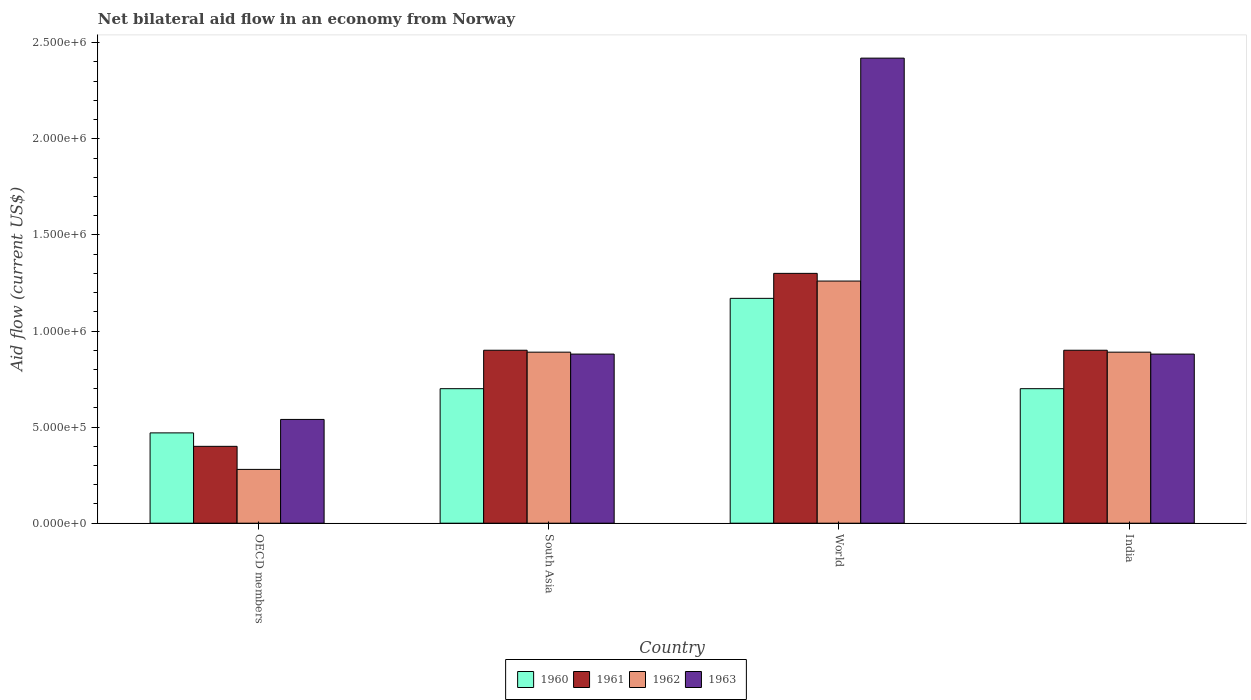How many different coloured bars are there?
Keep it short and to the point. 4. How many groups of bars are there?
Ensure brevity in your answer.  4. Are the number of bars per tick equal to the number of legend labels?
Offer a terse response. Yes. How many bars are there on the 4th tick from the right?
Offer a very short reply. 4. What is the net bilateral aid flow in 1960 in South Asia?
Ensure brevity in your answer.  7.00e+05. Across all countries, what is the maximum net bilateral aid flow in 1963?
Make the answer very short. 2.42e+06. Across all countries, what is the minimum net bilateral aid flow in 1961?
Your answer should be very brief. 4.00e+05. What is the total net bilateral aid flow in 1962 in the graph?
Your answer should be very brief. 3.32e+06. What is the difference between the net bilateral aid flow in 1962 in India and that in OECD members?
Your answer should be very brief. 6.10e+05. What is the difference between the net bilateral aid flow in 1963 in India and the net bilateral aid flow in 1962 in World?
Make the answer very short. -3.80e+05. What is the average net bilateral aid flow in 1960 per country?
Ensure brevity in your answer.  7.60e+05. What is the difference between the net bilateral aid flow of/in 1961 and net bilateral aid flow of/in 1963 in South Asia?
Your answer should be compact. 2.00e+04. What is the ratio of the net bilateral aid flow in 1960 in OECD members to that in South Asia?
Provide a succinct answer. 0.67. What is the difference between the highest and the lowest net bilateral aid flow in 1962?
Your response must be concise. 9.80e+05. Is the sum of the net bilateral aid flow in 1960 in South Asia and World greater than the maximum net bilateral aid flow in 1962 across all countries?
Your response must be concise. Yes. What does the 4th bar from the right in OECD members represents?
Offer a very short reply. 1960. Are all the bars in the graph horizontal?
Provide a succinct answer. No. What is the difference between two consecutive major ticks on the Y-axis?
Ensure brevity in your answer.  5.00e+05. Are the values on the major ticks of Y-axis written in scientific E-notation?
Give a very brief answer. Yes. How are the legend labels stacked?
Keep it short and to the point. Horizontal. What is the title of the graph?
Provide a succinct answer. Net bilateral aid flow in an economy from Norway. What is the Aid flow (current US$) of 1962 in OECD members?
Offer a terse response. 2.80e+05. What is the Aid flow (current US$) in 1963 in OECD members?
Your answer should be very brief. 5.40e+05. What is the Aid flow (current US$) in 1960 in South Asia?
Make the answer very short. 7.00e+05. What is the Aid flow (current US$) of 1962 in South Asia?
Offer a very short reply. 8.90e+05. What is the Aid flow (current US$) of 1963 in South Asia?
Your response must be concise. 8.80e+05. What is the Aid flow (current US$) in 1960 in World?
Ensure brevity in your answer.  1.17e+06. What is the Aid flow (current US$) in 1961 in World?
Your response must be concise. 1.30e+06. What is the Aid flow (current US$) of 1962 in World?
Ensure brevity in your answer.  1.26e+06. What is the Aid flow (current US$) of 1963 in World?
Your answer should be very brief. 2.42e+06. What is the Aid flow (current US$) of 1962 in India?
Make the answer very short. 8.90e+05. What is the Aid flow (current US$) in 1963 in India?
Make the answer very short. 8.80e+05. Across all countries, what is the maximum Aid flow (current US$) in 1960?
Offer a very short reply. 1.17e+06. Across all countries, what is the maximum Aid flow (current US$) of 1961?
Your answer should be compact. 1.30e+06. Across all countries, what is the maximum Aid flow (current US$) in 1962?
Your answer should be very brief. 1.26e+06. Across all countries, what is the maximum Aid flow (current US$) of 1963?
Offer a very short reply. 2.42e+06. Across all countries, what is the minimum Aid flow (current US$) of 1961?
Your answer should be very brief. 4.00e+05. Across all countries, what is the minimum Aid flow (current US$) of 1962?
Make the answer very short. 2.80e+05. Across all countries, what is the minimum Aid flow (current US$) in 1963?
Offer a very short reply. 5.40e+05. What is the total Aid flow (current US$) of 1960 in the graph?
Ensure brevity in your answer.  3.04e+06. What is the total Aid flow (current US$) of 1961 in the graph?
Your response must be concise. 3.50e+06. What is the total Aid flow (current US$) in 1962 in the graph?
Offer a very short reply. 3.32e+06. What is the total Aid flow (current US$) of 1963 in the graph?
Your answer should be very brief. 4.72e+06. What is the difference between the Aid flow (current US$) of 1960 in OECD members and that in South Asia?
Keep it short and to the point. -2.30e+05. What is the difference between the Aid flow (current US$) in 1961 in OECD members and that in South Asia?
Provide a succinct answer. -5.00e+05. What is the difference between the Aid flow (current US$) of 1962 in OECD members and that in South Asia?
Ensure brevity in your answer.  -6.10e+05. What is the difference between the Aid flow (current US$) of 1960 in OECD members and that in World?
Provide a short and direct response. -7.00e+05. What is the difference between the Aid flow (current US$) of 1961 in OECD members and that in World?
Your answer should be very brief. -9.00e+05. What is the difference between the Aid flow (current US$) of 1962 in OECD members and that in World?
Make the answer very short. -9.80e+05. What is the difference between the Aid flow (current US$) of 1963 in OECD members and that in World?
Provide a succinct answer. -1.88e+06. What is the difference between the Aid flow (current US$) of 1960 in OECD members and that in India?
Provide a succinct answer. -2.30e+05. What is the difference between the Aid flow (current US$) of 1961 in OECD members and that in India?
Your answer should be compact. -5.00e+05. What is the difference between the Aid flow (current US$) in 1962 in OECD members and that in India?
Provide a short and direct response. -6.10e+05. What is the difference between the Aid flow (current US$) in 1963 in OECD members and that in India?
Keep it short and to the point. -3.40e+05. What is the difference between the Aid flow (current US$) in 1960 in South Asia and that in World?
Make the answer very short. -4.70e+05. What is the difference between the Aid flow (current US$) of 1961 in South Asia and that in World?
Provide a short and direct response. -4.00e+05. What is the difference between the Aid flow (current US$) of 1962 in South Asia and that in World?
Offer a very short reply. -3.70e+05. What is the difference between the Aid flow (current US$) in 1963 in South Asia and that in World?
Keep it short and to the point. -1.54e+06. What is the difference between the Aid flow (current US$) of 1960 in South Asia and that in India?
Provide a short and direct response. 0. What is the difference between the Aid flow (current US$) of 1961 in South Asia and that in India?
Your answer should be very brief. 0. What is the difference between the Aid flow (current US$) of 1962 in South Asia and that in India?
Give a very brief answer. 0. What is the difference between the Aid flow (current US$) in 1960 in World and that in India?
Give a very brief answer. 4.70e+05. What is the difference between the Aid flow (current US$) of 1962 in World and that in India?
Your answer should be very brief. 3.70e+05. What is the difference between the Aid flow (current US$) in 1963 in World and that in India?
Keep it short and to the point. 1.54e+06. What is the difference between the Aid flow (current US$) in 1960 in OECD members and the Aid flow (current US$) in 1961 in South Asia?
Your response must be concise. -4.30e+05. What is the difference between the Aid flow (current US$) of 1960 in OECD members and the Aid flow (current US$) of 1962 in South Asia?
Your answer should be compact. -4.20e+05. What is the difference between the Aid flow (current US$) of 1960 in OECD members and the Aid flow (current US$) of 1963 in South Asia?
Ensure brevity in your answer.  -4.10e+05. What is the difference between the Aid flow (current US$) in 1961 in OECD members and the Aid flow (current US$) in 1962 in South Asia?
Provide a short and direct response. -4.90e+05. What is the difference between the Aid flow (current US$) of 1961 in OECD members and the Aid flow (current US$) of 1963 in South Asia?
Your response must be concise. -4.80e+05. What is the difference between the Aid flow (current US$) in 1962 in OECD members and the Aid flow (current US$) in 1963 in South Asia?
Your answer should be compact. -6.00e+05. What is the difference between the Aid flow (current US$) of 1960 in OECD members and the Aid flow (current US$) of 1961 in World?
Your response must be concise. -8.30e+05. What is the difference between the Aid flow (current US$) in 1960 in OECD members and the Aid flow (current US$) in 1962 in World?
Ensure brevity in your answer.  -7.90e+05. What is the difference between the Aid flow (current US$) of 1960 in OECD members and the Aid flow (current US$) of 1963 in World?
Provide a short and direct response. -1.95e+06. What is the difference between the Aid flow (current US$) of 1961 in OECD members and the Aid flow (current US$) of 1962 in World?
Ensure brevity in your answer.  -8.60e+05. What is the difference between the Aid flow (current US$) of 1961 in OECD members and the Aid flow (current US$) of 1963 in World?
Your answer should be compact. -2.02e+06. What is the difference between the Aid flow (current US$) in 1962 in OECD members and the Aid flow (current US$) in 1963 in World?
Ensure brevity in your answer.  -2.14e+06. What is the difference between the Aid flow (current US$) in 1960 in OECD members and the Aid flow (current US$) in 1961 in India?
Offer a terse response. -4.30e+05. What is the difference between the Aid flow (current US$) in 1960 in OECD members and the Aid flow (current US$) in 1962 in India?
Your response must be concise. -4.20e+05. What is the difference between the Aid flow (current US$) of 1960 in OECD members and the Aid flow (current US$) of 1963 in India?
Ensure brevity in your answer.  -4.10e+05. What is the difference between the Aid flow (current US$) of 1961 in OECD members and the Aid flow (current US$) of 1962 in India?
Keep it short and to the point. -4.90e+05. What is the difference between the Aid flow (current US$) in 1961 in OECD members and the Aid flow (current US$) in 1963 in India?
Your answer should be very brief. -4.80e+05. What is the difference between the Aid flow (current US$) of 1962 in OECD members and the Aid flow (current US$) of 1963 in India?
Make the answer very short. -6.00e+05. What is the difference between the Aid flow (current US$) of 1960 in South Asia and the Aid flow (current US$) of 1961 in World?
Your answer should be very brief. -6.00e+05. What is the difference between the Aid flow (current US$) in 1960 in South Asia and the Aid flow (current US$) in 1962 in World?
Your answer should be compact. -5.60e+05. What is the difference between the Aid flow (current US$) of 1960 in South Asia and the Aid flow (current US$) of 1963 in World?
Your answer should be very brief. -1.72e+06. What is the difference between the Aid flow (current US$) in 1961 in South Asia and the Aid flow (current US$) in 1962 in World?
Offer a very short reply. -3.60e+05. What is the difference between the Aid flow (current US$) of 1961 in South Asia and the Aid flow (current US$) of 1963 in World?
Offer a terse response. -1.52e+06. What is the difference between the Aid flow (current US$) of 1962 in South Asia and the Aid flow (current US$) of 1963 in World?
Ensure brevity in your answer.  -1.53e+06. What is the difference between the Aid flow (current US$) of 1960 in South Asia and the Aid flow (current US$) of 1961 in India?
Keep it short and to the point. -2.00e+05. What is the difference between the Aid flow (current US$) of 1960 in South Asia and the Aid flow (current US$) of 1962 in India?
Your answer should be very brief. -1.90e+05. What is the difference between the Aid flow (current US$) of 1960 in South Asia and the Aid flow (current US$) of 1963 in India?
Offer a very short reply. -1.80e+05. What is the difference between the Aid flow (current US$) of 1961 in South Asia and the Aid flow (current US$) of 1962 in India?
Your answer should be very brief. 10000. What is the difference between the Aid flow (current US$) in 1960 in World and the Aid flow (current US$) in 1961 in India?
Offer a very short reply. 2.70e+05. What is the difference between the Aid flow (current US$) in 1960 in World and the Aid flow (current US$) in 1962 in India?
Your response must be concise. 2.80e+05. What is the difference between the Aid flow (current US$) of 1962 in World and the Aid flow (current US$) of 1963 in India?
Give a very brief answer. 3.80e+05. What is the average Aid flow (current US$) in 1960 per country?
Offer a very short reply. 7.60e+05. What is the average Aid flow (current US$) in 1961 per country?
Make the answer very short. 8.75e+05. What is the average Aid flow (current US$) in 1962 per country?
Give a very brief answer. 8.30e+05. What is the average Aid flow (current US$) of 1963 per country?
Keep it short and to the point. 1.18e+06. What is the difference between the Aid flow (current US$) in 1960 and Aid flow (current US$) in 1961 in OECD members?
Offer a very short reply. 7.00e+04. What is the difference between the Aid flow (current US$) of 1960 and Aid flow (current US$) of 1963 in OECD members?
Keep it short and to the point. -7.00e+04. What is the difference between the Aid flow (current US$) of 1961 and Aid flow (current US$) of 1962 in OECD members?
Give a very brief answer. 1.20e+05. What is the difference between the Aid flow (current US$) of 1962 and Aid flow (current US$) of 1963 in OECD members?
Make the answer very short. -2.60e+05. What is the difference between the Aid flow (current US$) of 1960 and Aid flow (current US$) of 1962 in South Asia?
Give a very brief answer. -1.90e+05. What is the difference between the Aid flow (current US$) in 1960 and Aid flow (current US$) in 1963 in World?
Your answer should be very brief. -1.25e+06. What is the difference between the Aid flow (current US$) in 1961 and Aid flow (current US$) in 1962 in World?
Provide a short and direct response. 4.00e+04. What is the difference between the Aid flow (current US$) in 1961 and Aid flow (current US$) in 1963 in World?
Your response must be concise. -1.12e+06. What is the difference between the Aid flow (current US$) in 1962 and Aid flow (current US$) in 1963 in World?
Offer a terse response. -1.16e+06. What is the difference between the Aid flow (current US$) of 1960 and Aid flow (current US$) of 1961 in India?
Your answer should be compact. -2.00e+05. What is the difference between the Aid flow (current US$) of 1960 and Aid flow (current US$) of 1963 in India?
Provide a succinct answer. -1.80e+05. What is the difference between the Aid flow (current US$) of 1961 and Aid flow (current US$) of 1963 in India?
Provide a short and direct response. 2.00e+04. What is the ratio of the Aid flow (current US$) in 1960 in OECD members to that in South Asia?
Your answer should be very brief. 0.67. What is the ratio of the Aid flow (current US$) of 1961 in OECD members to that in South Asia?
Your response must be concise. 0.44. What is the ratio of the Aid flow (current US$) of 1962 in OECD members to that in South Asia?
Provide a succinct answer. 0.31. What is the ratio of the Aid flow (current US$) in 1963 in OECD members to that in South Asia?
Your response must be concise. 0.61. What is the ratio of the Aid flow (current US$) in 1960 in OECD members to that in World?
Offer a terse response. 0.4. What is the ratio of the Aid flow (current US$) in 1961 in OECD members to that in World?
Offer a terse response. 0.31. What is the ratio of the Aid flow (current US$) in 1962 in OECD members to that in World?
Offer a very short reply. 0.22. What is the ratio of the Aid flow (current US$) of 1963 in OECD members to that in World?
Keep it short and to the point. 0.22. What is the ratio of the Aid flow (current US$) of 1960 in OECD members to that in India?
Offer a very short reply. 0.67. What is the ratio of the Aid flow (current US$) of 1961 in OECD members to that in India?
Ensure brevity in your answer.  0.44. What is the ratio of the Aid flow (current US$) of 1962 in OECD members to that in India?
Offer a very short reply. 0.31. What is the ratio of the Aid flow (current US$) in 1963 in OECD members to that in India?
Give a very brief answer. 0.61. What is the ratio of the Aid flow (current US$) in 1960 in South Asia to that in World?
Your response must be concise. 0.6. What is the ratio of the Aid flow (current US$) in 1961 in South Asia to that in World?
Provide a short and direct response. 0.69. What is the ratio of the Aid flow (current US$) of 1962 in South Asia to that in World?
Provide a succinct answer. 0.71. What is the ratio of the Aid flow (current US$) in 1963 in South Asia to that in World?
Ensure brevity in your answer.  0.36. What is the ratio of the Aid flow (current US$) in 1961 in South Asia to that in India?
Your response must be concise. 1. What is the ratio of the Aid flow (current US$) of 1962 in South Asia to that in India?
Ensure brevity in your answer.  1. What is the ratio of the Aid flow (current US$) of 1963 in South Asia to that in India?
Provide a short and direct response. 1. What is the ratio of the Aid flow (current US$) of 1960 in World to that in India?
Keep it short and to the point. 1.67. What is the ratio of the Aid flow (current US$) of 1961 in World to that in India?
Your answer should be very brief. 1.44. What is the ratio of the Aid flow (current US$) of 1962 in World to that in India?
Keep it short and to the point. 1.42. What is the ratio of the Aid flow (current US$) of 1963 in World to that in India?
Provide a succinct answer. 2.75. What is the difference between the highest and the second highest Aid flow (current US$) in 1961?
Your response must be concise. 4.00e+05. What is the difference between the highest and the second highest Aid flow (current US$) in 1963?
Your answer should be very brief. 1.54e+06. What is the difference between the highest and the lowest Aid flow (current US$) of 1960?
Your response must be concise. 7.00e+05. What is the difference between the highest and the lowest Aid flow (current US$) in 1961?
Give a very brief answer. 9.00e+05. What is the difference between the highest and the lowest Aid flow (current US$) in 1962?
Make the answer very short. 9.80e+05. What is the difference between the highest and the lowest Aid flow (current US$) of 1963?
Offer a terse response. 1.88e+06. 